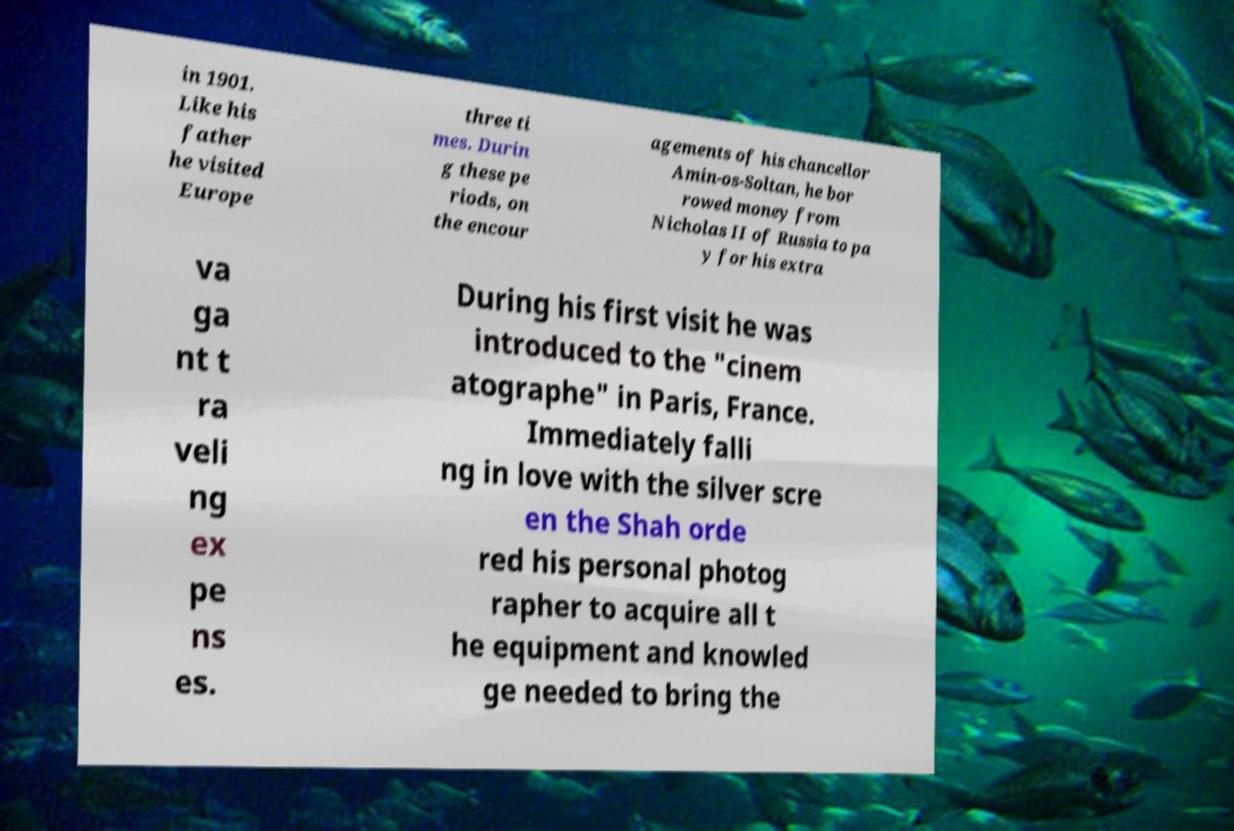I need the written content from this picture converted into text. Can you do that? in 1901. Like his father he visited Europe three ti mes. Durin g these pe riods, on the encour agements of his chancellor Amin-os-Soltan, he bor rowed money from Nicholas II of Russia to pa y for his extra va ga nt t ra veli ng ex pe ns es. During his first visit he was introduced to the "cinem atographe" in Paris, France. Immediately falli ng in love with the silver scre en the Shah orde red his personal photog rapher to acquire all t he equipment and knowled ge needed to bring the 